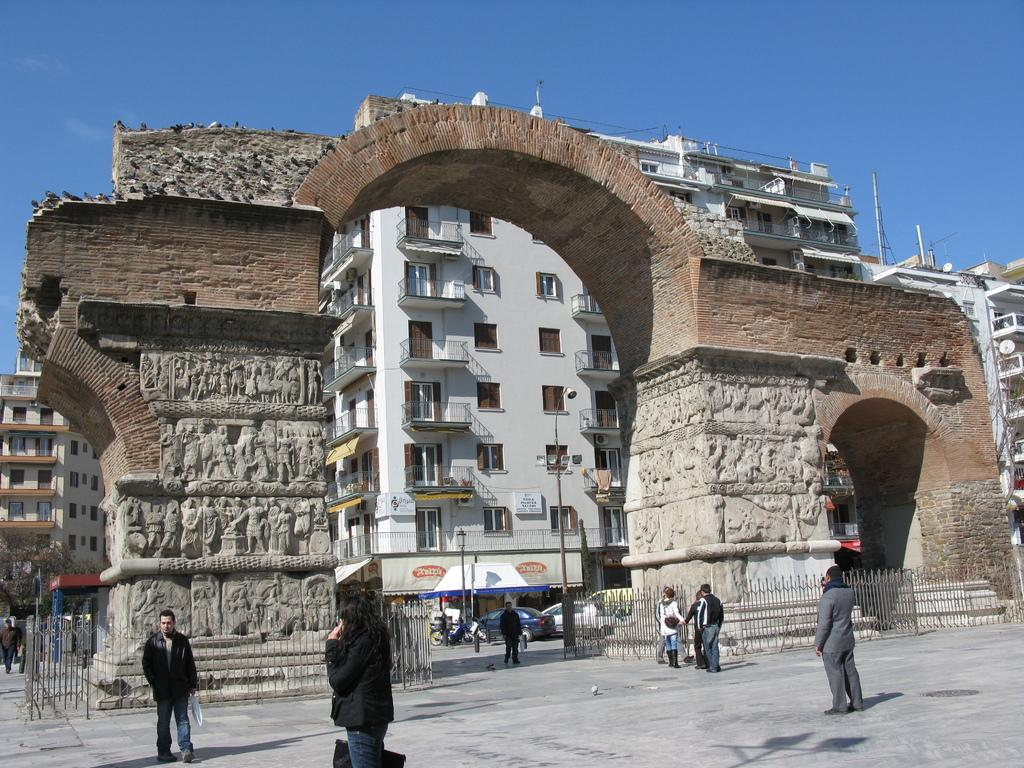What type of structures can be seen in the image? There are buildings in the image. What separates the buildings from the ground in the image? There is a fence in the image. What are the people in the image doing? There are people standing on the ground in the image. What are the poles used for in the image? The poles are likely used for supporting wires or signs in the image. What type of transportation is visible in the image? There are vehicles in the image. What other objects can be seen on the ground in the image? There are other objects on the ground in the image, but their specific purpose is not clear. What can be seen in the background of the image? The sky is visible in the background of the image. Where is the sink located in the image? There is no sink present in the image. What type of punishment is being administered to the people in the image? There is no indication of punishment in the image; the people are simply standing on the ground. 